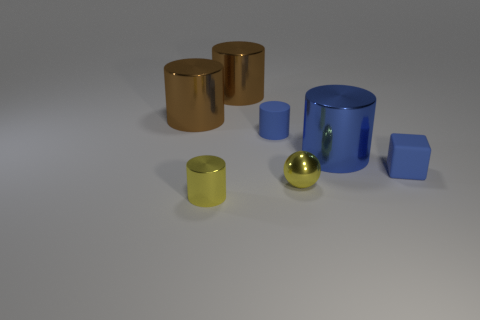Subtract all tiny blue rubber cylinders. How many cylinders are left? 4 Add 1 metallic objects. How many objects exist? 8 Subtract 1 cylinders. How many cylinders are left? 4 Subtract all brown cylinders. How many cylinders are left? 3 Subtract all yellow spheres. How many brown cylinders are left? 2 Subtract 0 cyan cylinders. How many objects are left? 7 Subtract all spheres. How many objects are left? 6 Subtract all cyan blocks. Subtract all cyan spheres. How many blocks are left? 1 Subtract all small blue things. Subtract all brown cubes. How many objects are left? 5 Add 1 brown shiny objects. How many brown shiny objects are left? 3 